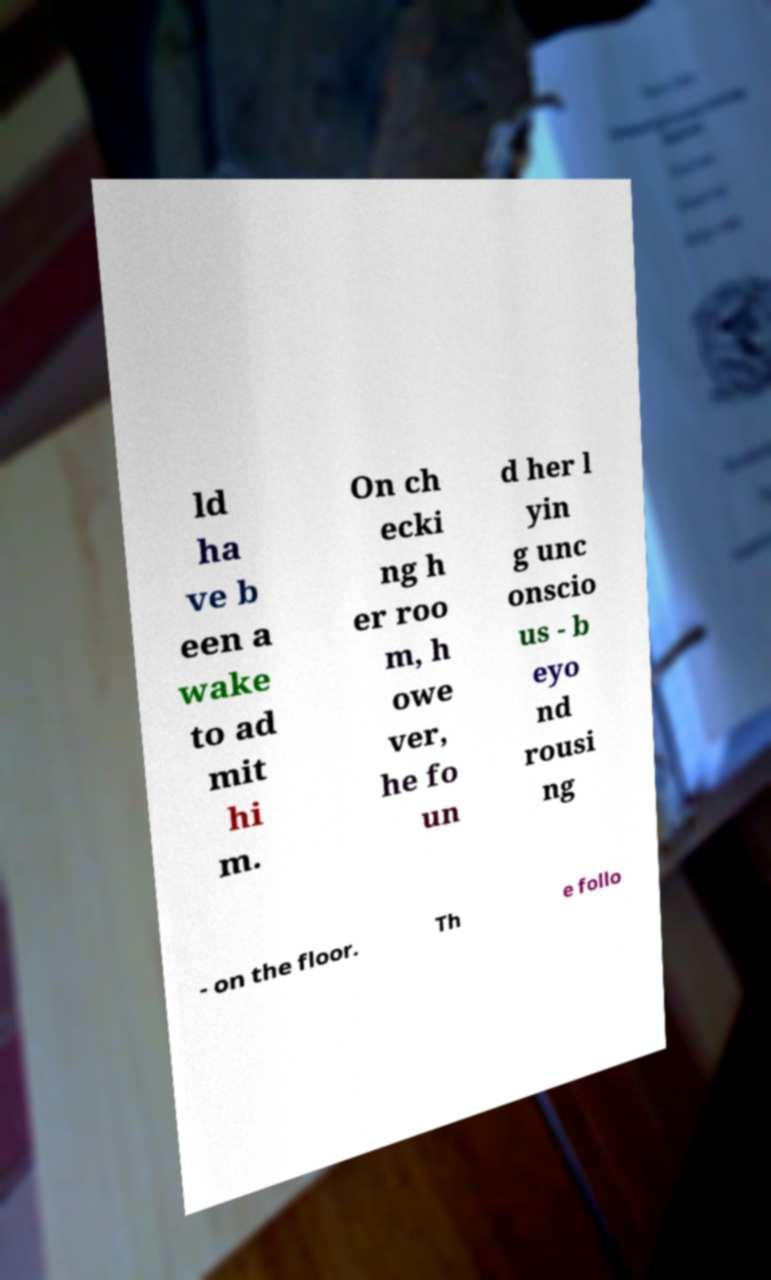What messages or text are displayed in this image? I need them in a readable, typed format. ld ha ve b een a wake to ad mit hi m. On ch ecki ng h er roo m, h owe ver, he fo un d her l yin g unc onscio us - b eyo nd rousi ng - on the floor. Th e follo 